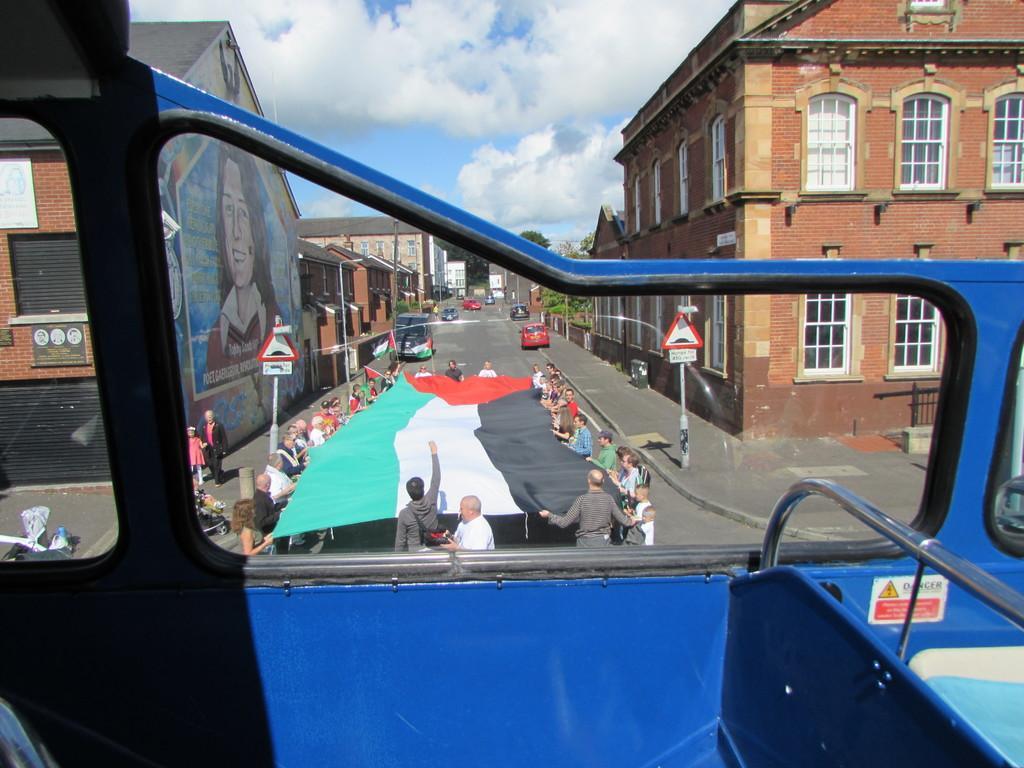How would you summarize this image in a sentence or two? In this picture we can see a vehicle with a glass and behind the vehicle there are groups of people standing and holding a flag. On the left and right side of the people there are poles with sign boards on the path. Behind the people there are some vehicles on the road, buildings, trees and a cloudy sky. 